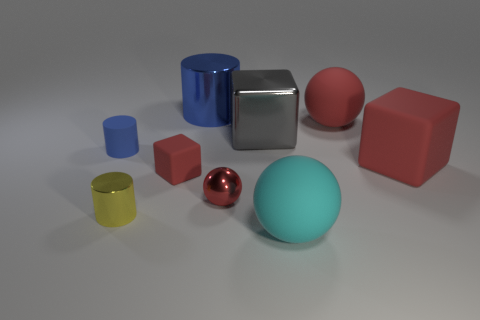There is a gray block that is the same material as the tiny yellow object; what is its size?
Your answer should be very brief. Large. Are there fewer metal blocks than small metal objects?
Offer a terse response. Yes. What is the blue cylinder behind the thing that is to the left of the shiny object that is to the left of the large shiny cylinder made of?
Make the answer very short. Metal. Do the big red thing in front of the large gray cube and the large thing that is in front of the big red rubber cube have the same material?
Your answer should be very brief. Yes. How big is the sphere that is both on the right side of the small red shiny object and behind the small yellow metallic object?
Provide a short and direct response. Large. There is another sphere that is the same size as the cyan matte sphere; what is it made of?
Give a very brief answer. Rubber. There is a large ball on the right side of the big object that is in front of the tiny red matte cube; how many big red matte objects are behind it?
Offer a very short reply. 0. Do the metal cylinder in front of the large blue object and the thing in front of the small yellow thing have the same color?
Make the answer very short. No. What is the color of the object that is both in front of the tiny red sphere and on the left side of the big cylinder?
Keep it short and to the point. Yellow. What number of red metallic objects have the same size as the cyan matte thing?
Offer a very short reply. 0. 